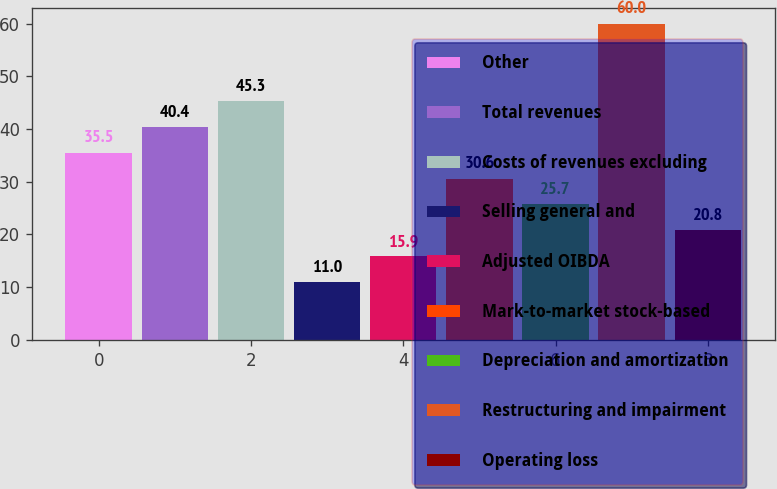Convert chart to OTSL. <chart><loc_0><loc_0><loc_500><loc_500><bar_chart><fcel>Other<fcel>Total revenues<fcel>Costs of revenues excluding<fcel>Selling general and<fcel>Adjusted OIBDA<fcel>Mark-to-market stock-based<fcel>Depreciation and amortization<fcel>Restructuring and impairment<fcel>Operating loss<nl><fcel>35.5<fcel>40.4<fcel>45.3<fcel>11<fcel>15.9<fcel>30.6<fcel>25.7<fcel>60<fcel>20.8<nl></chart> 